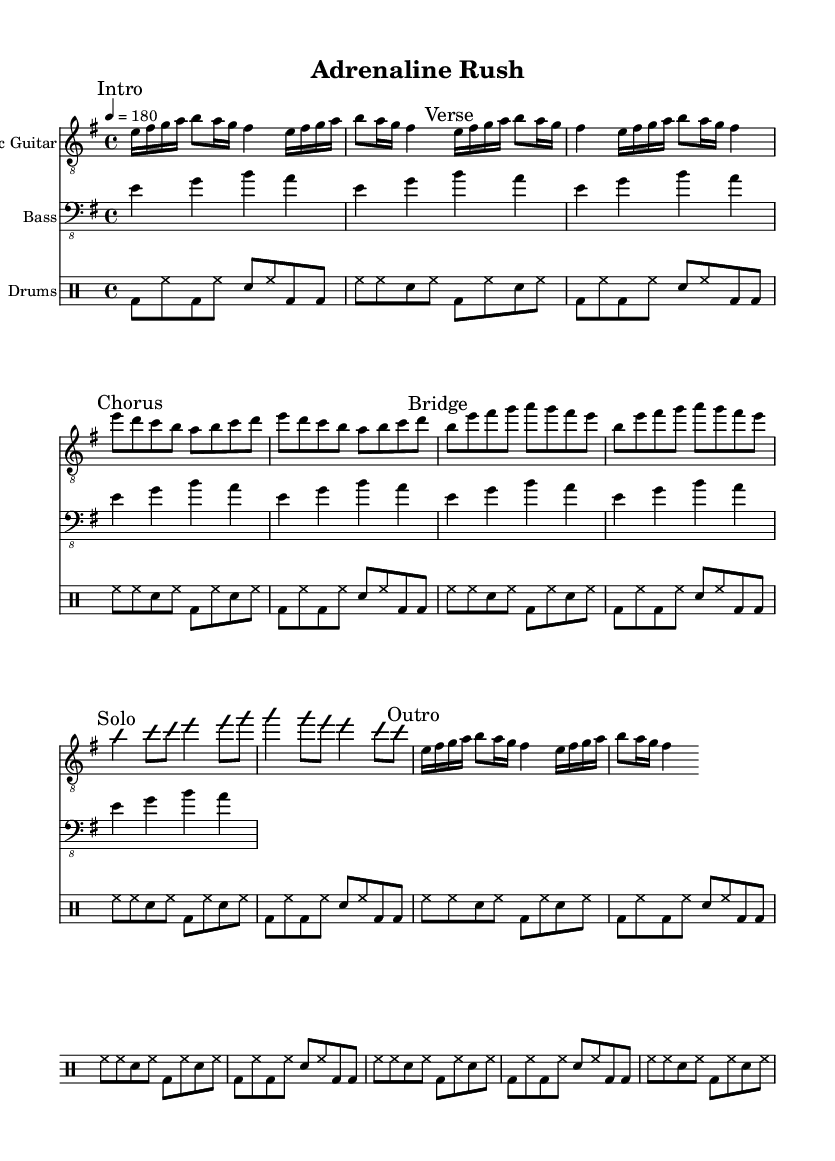What is the key signature of this music? The key signature is E minor, which includes one sharp (F#) and corresponds to its relative major, G major.
Answer: E minor What is the time signature of this music? The time signature is indicated at the beginning of the score as 4/4, meaning four beats per measure with a quarter note receiving one beat.
Answer: 4/4 What is the tempo marking in beats per minute? The tempo is indicated as quarter note equals 180, meaning there are 180 beats in a minute.
Answer: 180 How many times is the verse repeated? The verse section is marked to be repeated 2 times as indicated by the repeat signs and the "repeat unfold 2" instruction.
Answer: 2 Which section contains a solo? The section marked "Solo" follows immediately after the "Bridge" and consists of an improvisational section.
Answer: Solo What is the main rhythm pattern for the drums? The rhythm pattern consists of a combination of bass drum, snare drum, and hi-hat features, which are repeated through the song section. This is characterized by a basic rock beat that is common in thrash metal.
Answer: Basic rock beat What instrument is playing the main riff? The main riff is being played by the bass guitar, as indicated in the score, with simple notes that align with the energetic tempo of thrash metal.
Answer: Bass guitar 